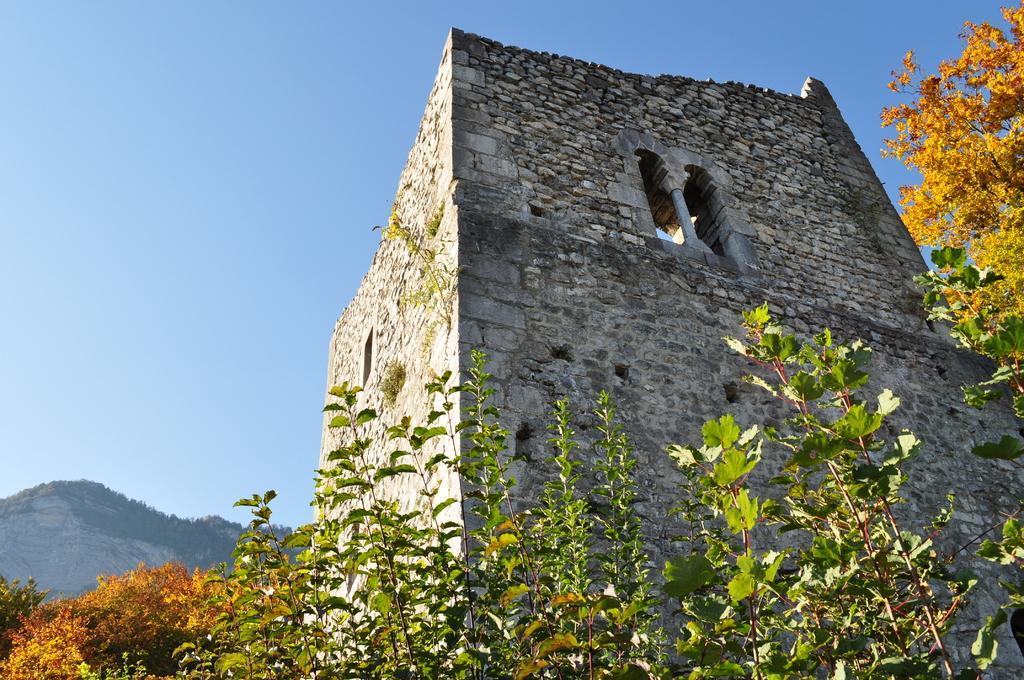In one or two sentences, can you explain what this image depicts? In this image we can see a building with windows. In the foreground we can see some plants. In the background, we can see a group of trees, hill and the sky. 